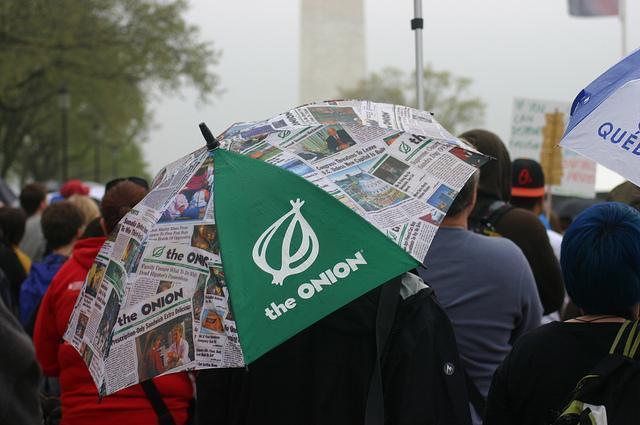How many people are visible?
Give a very brief answer. 6. How many backpacks are in the photo?
Give a very brief answer. 2. How many umbrellas are there?
Give a very brief answer. 2. 